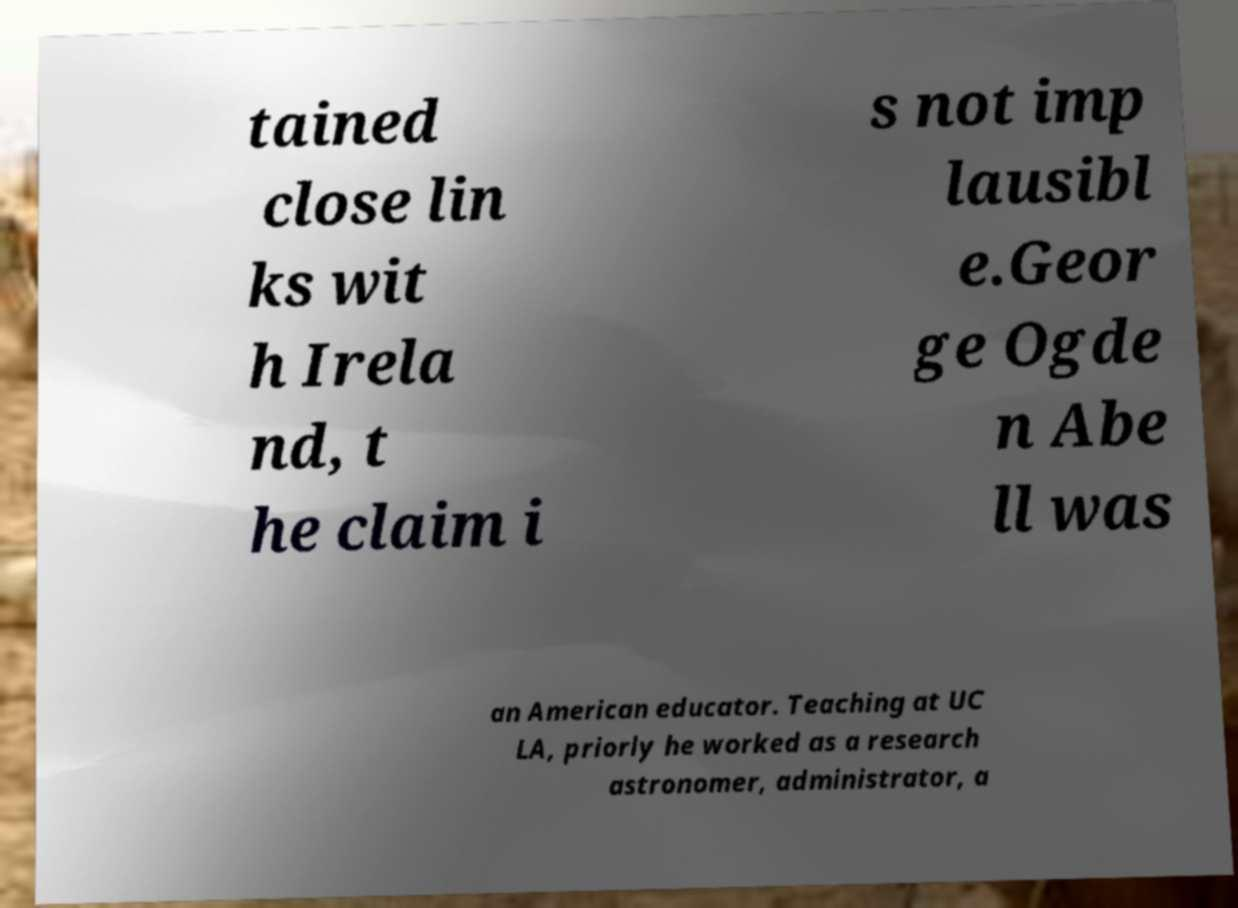Please identify and transcribe the text found in this image. tained close lin ks wit h Irela nd, t he claim i s not imp lausibl e.Geor ge Ogde n Abe ll was an American educator. Teaching at UC LA, priorly he worked as a research astronomer, administrator, a 